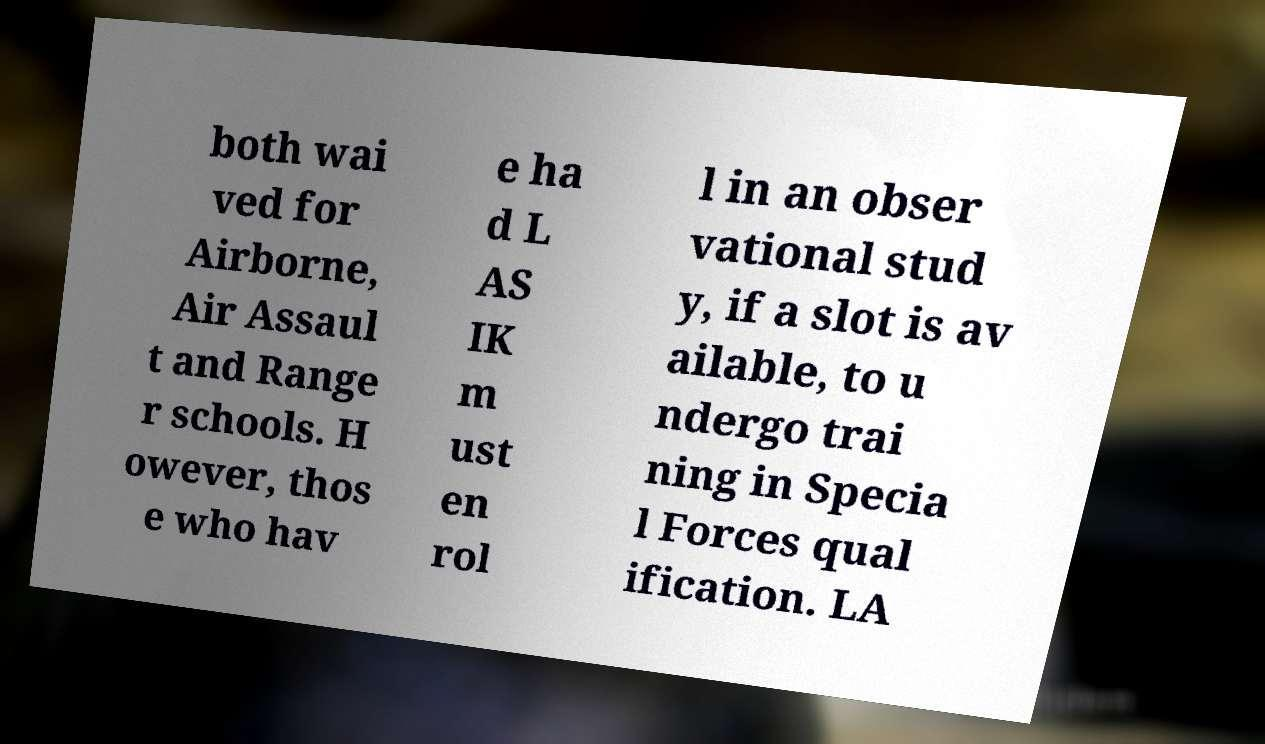Could you extract and type out the text from this image? both wai ved for Airborne, Air Assaul t and Range r schools. H owever, thos e who hav e ha d L AS IK m ust en rol l in an obser vational stud y, if a slot is av ailable, to u ndergo trai ning in Specia l Forces qual ification. LA 